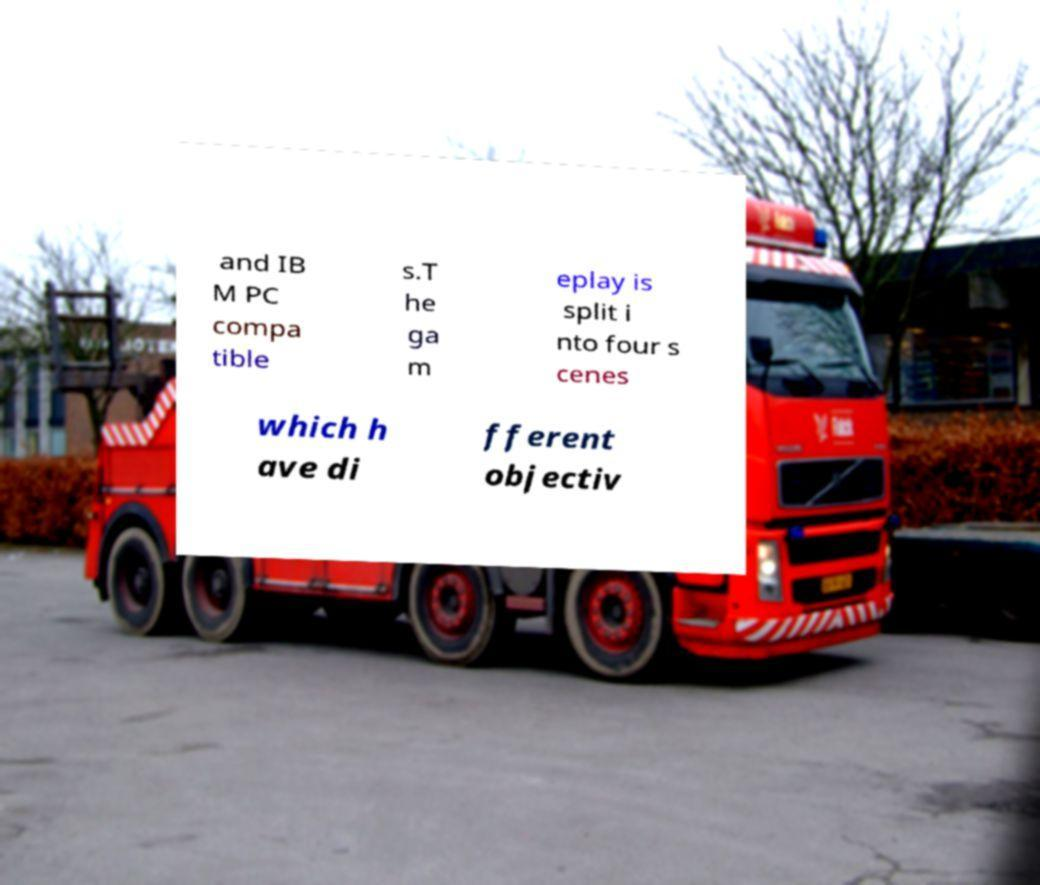There's text embedded in this image that I need extracted. Can you transcribe it verbatim? and IB M PC compa tible s.T he ga m eplay is split i nto four s cenes which h ave di fferent objectiv 